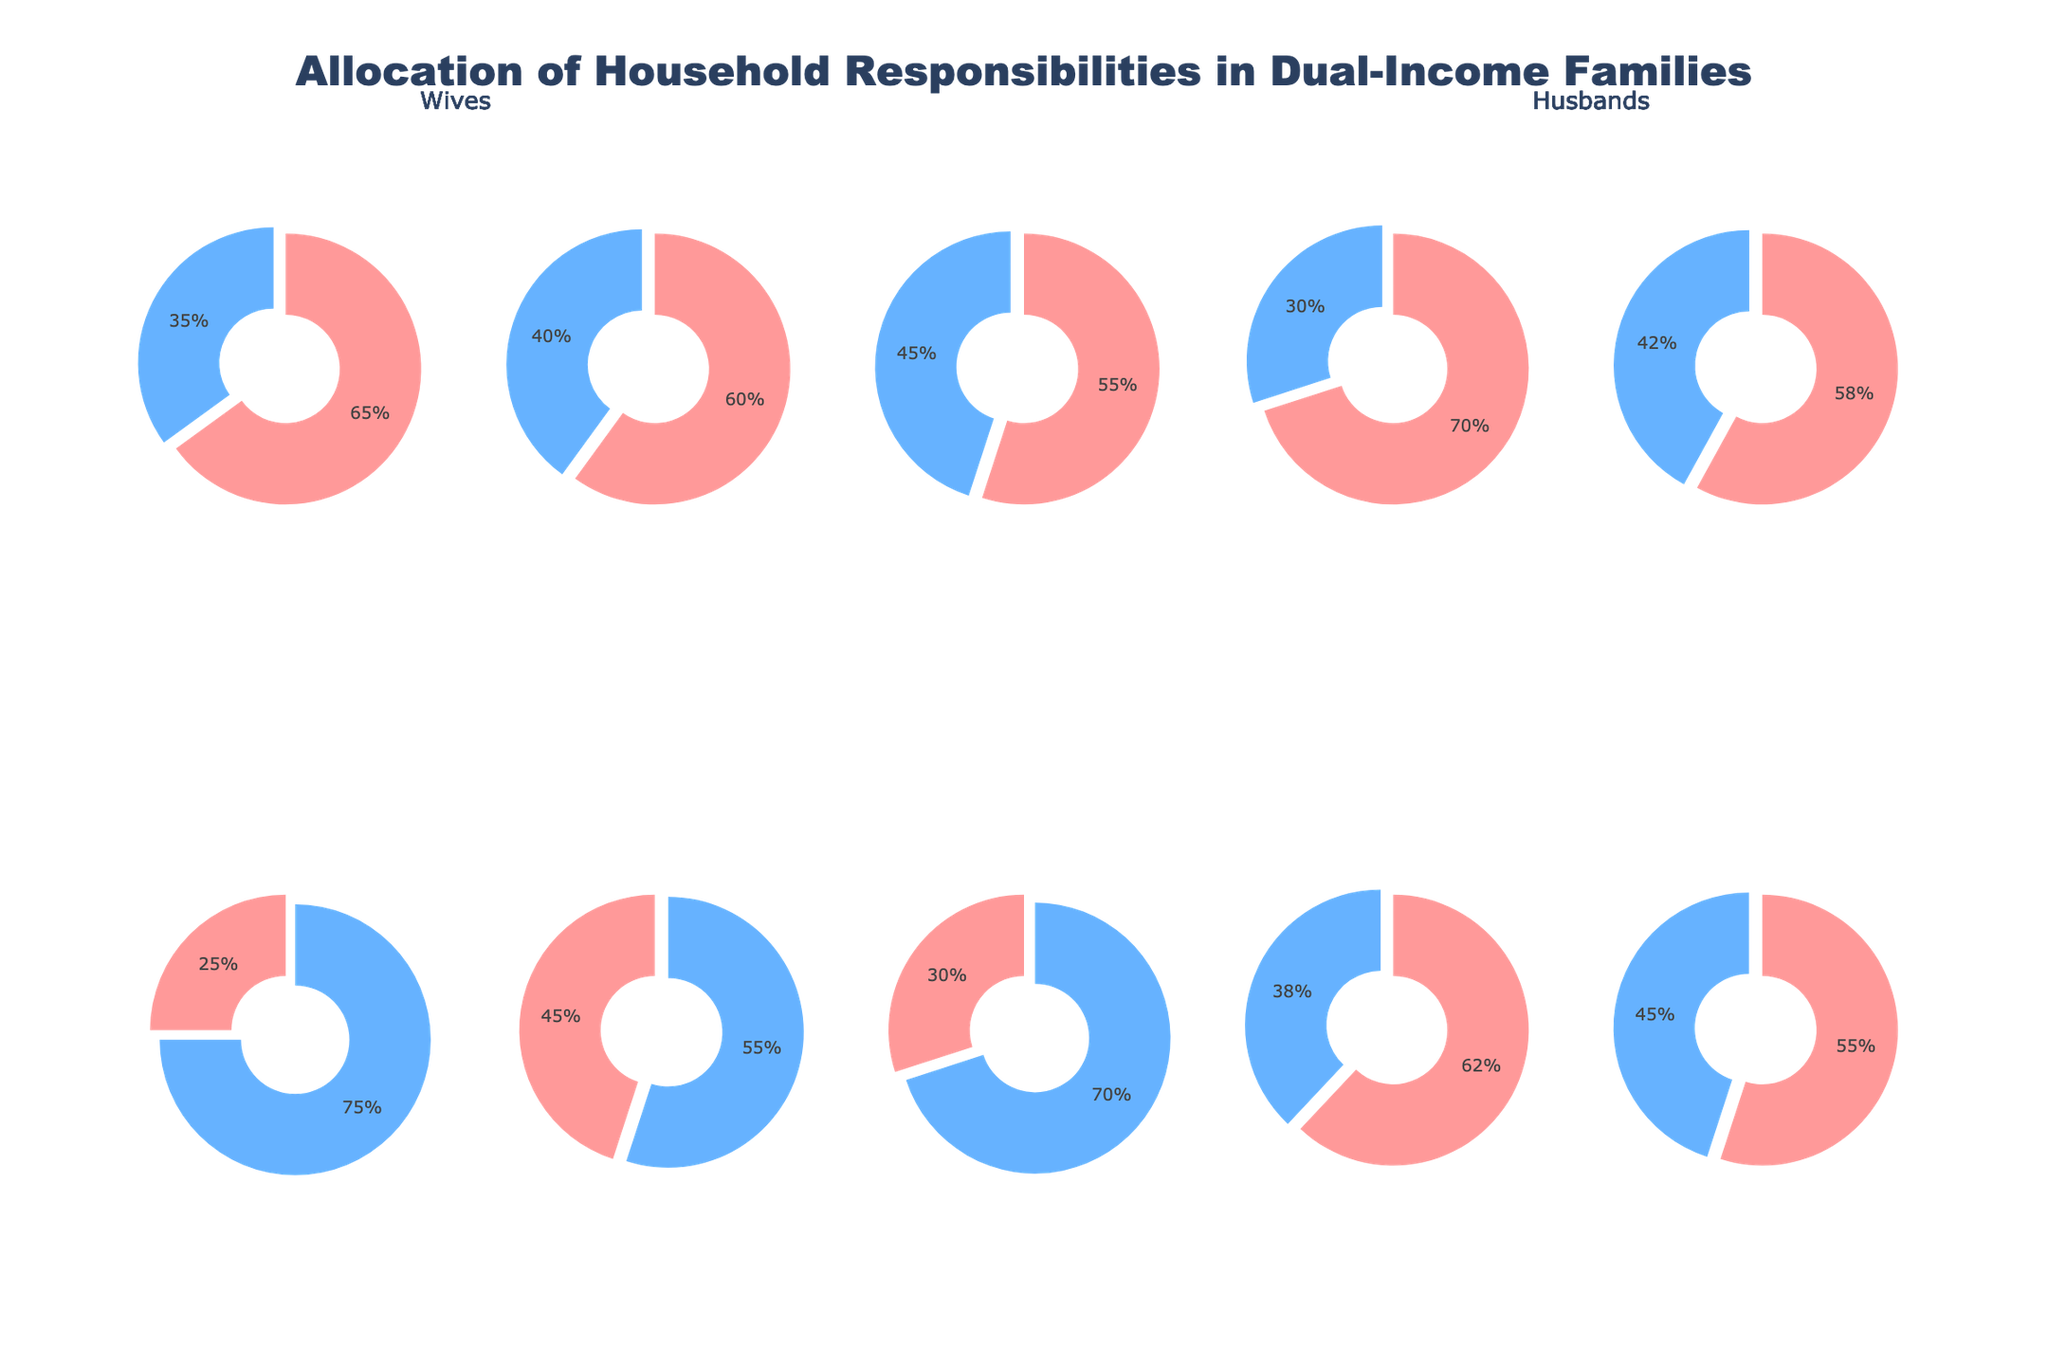Which household responsibility has the highest percentage of allocation to wives? Look at the pie charts and find the one with the largest percentage for wives. The "Laundry" task shows the highest percentage allocated to wives at 70%.
Answer: Laundry Which task shows a nearly equal allocation of responsibilities between wives and husbands? Identify the task that has the closest percentage values for both wives and husbands. The task "Childcare" shows an allocation of 55% to wives and 45% to husbands, which is close to equal.
Answer: Childcare What percentage of yard work is done by husbands? Observe the pie chart labeled "Yard work" and note the percentage for husbands. The yard work chart shows that 70% of the responsibility is taken by husbands.
Answer: 70% How many tasks have more than 60% allocation to wives? Count the number of pie charts where the allocation to wives is greater than 60%. The tasks "Cooking," "Cleaning," "Laundry," and "Scheduling appointments" each have over 60% allocation to wives.
Answer: 4 For which tasks do husbands take on more than half of the responsibilities? Look at the pie charts for tasks where the husband's percentage is greater than 50%. These tasks are "Home maintenance," "Financial management," and "Yard work".
Answer: 3 Which responsibility is most equally split between wives and husbands? Find the pie chart with the smallest difference between the percentages allocated to wives and husbands. "Childcare" has the smallest difference with a split of 55% for wives and 45% for husbands.
Answer: Childcare Are there more tasks where wives take on greater responsibilities or where husbands take on greater responsibilities? Count the number of tasks where the percentage for wives is greater than 50% and compare it to the number where the percentage for husbands is greater. There are more tasks where wives take on greater responsibilities with 7 tasks compared to 3 tasks for husbands.
Answer: Wives Which task has the highest allocation to husbands? Look at all the pie charts and identify the task where husbands have the highest percentage. "Home maintenance" shows the highest allocation to husbands at 75%.
Answer: Home maintenance How does the allocation for financial management compare to pet care between wives and husbands? Compare the pie charts for "Financial management" and "Pet care." Financial management shows 45% for wives and 55% for husbands, while pet care shows 55% for wives and 45% for husbands. Wives take on less financial management but more pet care.
Answer: Financial management: Husbands more; Pet care: Wives more 